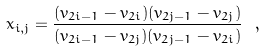<formula> <loc_0><loc_0><loc_500><loc_500>x _ { i , j } = \frac { ( v _ { 2 i - 1 } - v _ { 2 i } ) ( v _ { 2 j - 1 } - v _ { 2 j } ) } { ( v _ { 2 i - 1 } - v _ { 2 j } ) ( v _ { 2 j - 1 } - v _ { 2 i } ) } \ ,</formula> 